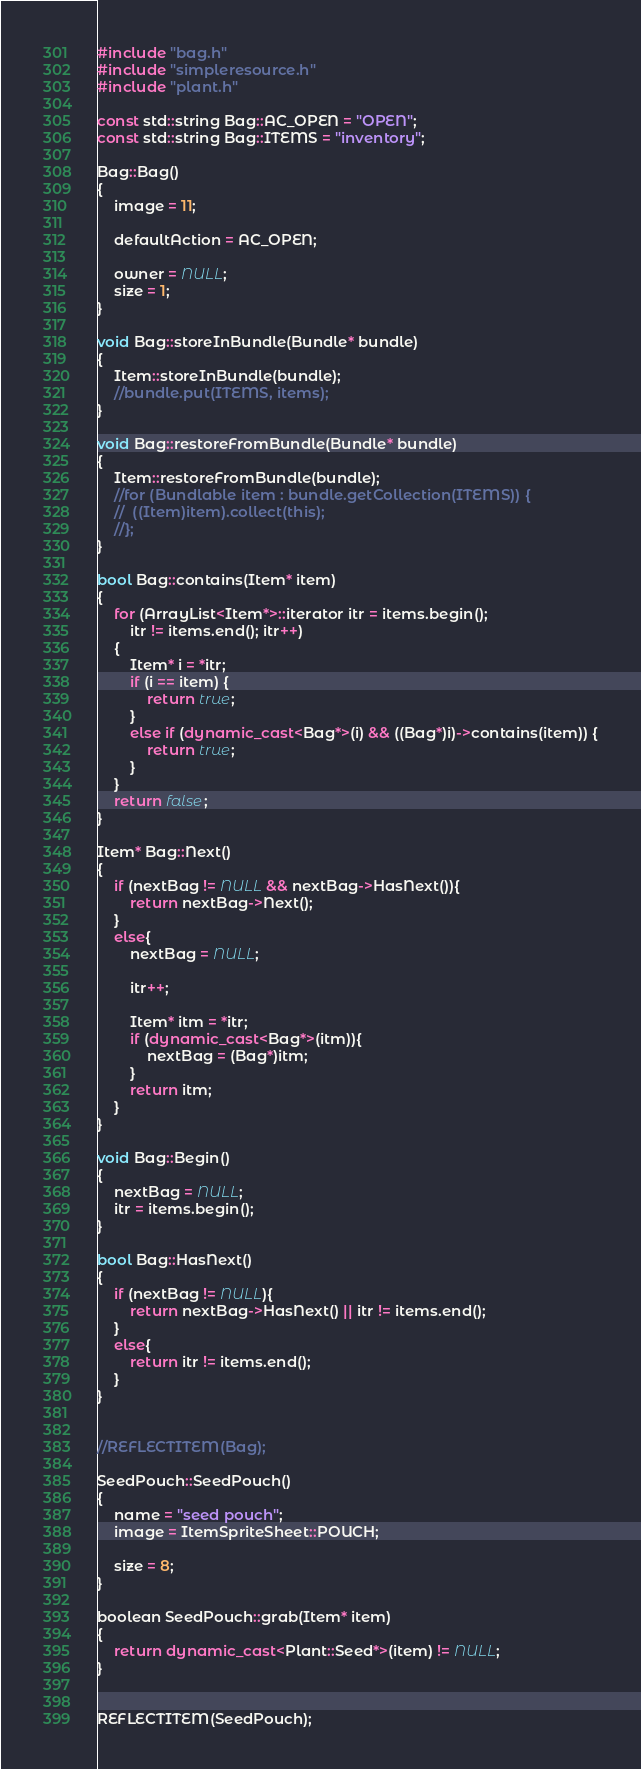<code> <loc_0><loc_0><loc_500><loc_500><_C++_>#include "bag.h"
#include "simpleresource.h"
#include "plant.h"

const std::string Bag::AC_OPEN = "OPEN";
const std::string Bag::ITEMS = "inventory";

Bag::Bag()
{
	image = 11;

	defaultAction = AC_OPEN;

	owner = NULL;
	size = 1;
}

void Bag::storeInBundle(Bundle* bundle)
{
	Item::storeInBundle(bundle);
	//bundle.put(ITEMS, items);
}

void Bag::restoreFromBundle(Bundle* bundle)
{
	Item::restoreFromBundle(bundle);
	//for (Bundlable item : bundle.getCollection(ITEMS)) {
	//	((Item)item).collect(this);
	//};
}

bool Bag::contains(Item* item)
{
	for (ArrayList<Item*>::iterator itr = items.begin();
		itr != items.end(); itr++)
	{
		Item* i = *itr;
		if (i == item) {
			return true;
		}
		else if (dynamic_cast<Bag*>(i) && ((Bag*)i)->contains(item)) {
			return true;
		}
	}
	return false;
}

Item* Bag::Next()
{
	if (nextBag != NULL && nextBag->HasNext()){
		return nextBag->Next();
	}
	else{
		nextBag = NULL;

		itr++;

		Item* itm = *itr;
		if (dynamic_cast<Bag*>(itm)){
			nextBag = (Bag*)itm;
		}
		return itm;
	}
}

void Bag::Begin()
{
	nextBag = NULL;
	itr = items.begin();
}

bool Bag::HasNext()
{
	if (nextBag != NULL){
		return nextBag->HasNext() || itr != items.end();
	}
	else{
		return itr != items.end();
	}
}


//REFLECTITEM(Bag);

SeedPouch::SeedPouch()
{
	name = "seed pouch";
	image = ItemSpriteSheet::POUCH;

	size = 8;
}

boolean SeedPouch::grab(Item* item)
{
	return dynamic_cast<Plant::Seed*>(item) != NULL;
}


REFLECTITEM(SeedPouch);</code> 